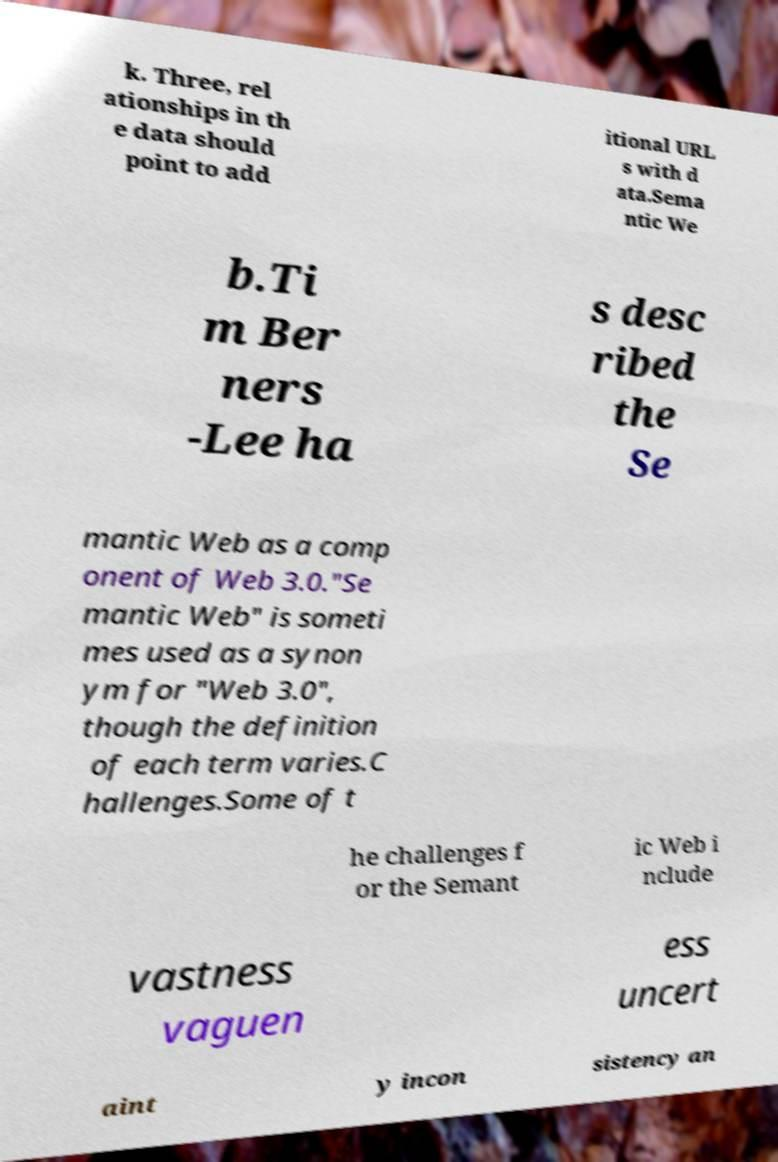Could you extract and type out the text from this image? k. Three, rel ationships in th e data should point to add itional URL s with d ata.Sema ntic We b.Ti m Ber ners -Lee ha s desc ribed the Se mantic Web as a comp onent of Web 3.0."Se mantic Web" is someti mes used as a synon ym for "Web 3.0", though the definition of each term varies.C hallenges.Some of t he challenges f or the Semant ic Web i nclude vastness vaguen ess uncert aint y incon sistency an 